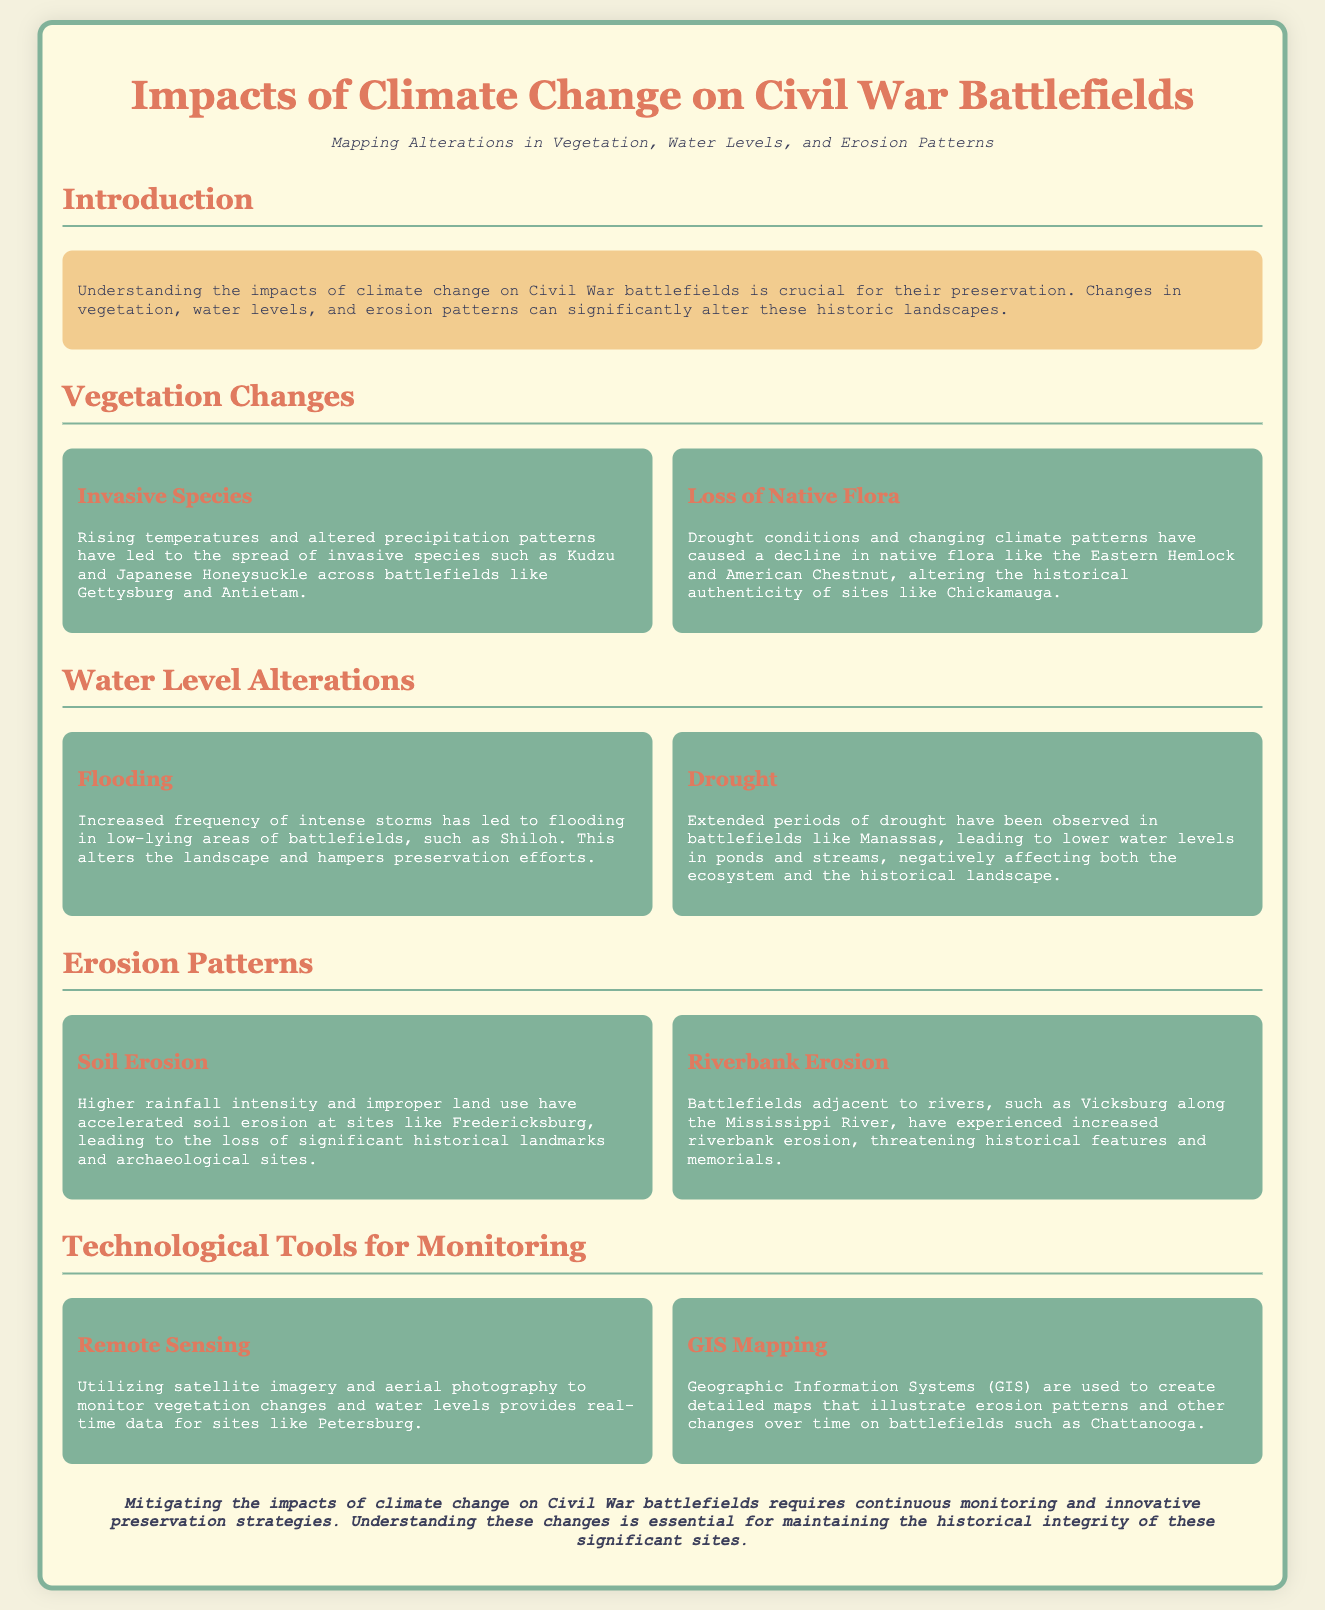What are two invasive species mentioned? The document states that rising temperatures and altered precipitation patterns have led to the spread of invasive species such as Kudzu and Japanese Honeysuckle.
Answer: Kudzu and Japanese Honeysuckle What is one native flora mentioned that is declining? Drought conditions and changing climate patterns have caused a decline in native flora like the Eastern Hemlock and American Chestnut.
Answer: Eastern Hemlock Which battlefield experienced flooding? The document indicates that increased frequency of intense storms has led to flooding in low-lying areas of battlefields, such as Shiloh.
Answer: Shiloh What technological tool is used to monitor vegetation changes? The document mentions using satellite imagery and aerial photography to monitor vegetation changes as part of Remote Sensing.
Answer: Remote Sensing What is a consequence of extended periods of drought on battlefields? The document states that extended periods of drought have been observed in battlefields like Manassas, leading to lower water levels in ponds and streams.
Answer: Lower water levels What type of erosion is exacerbated by higher rainfall intensity? The document notes that higher rainfall intensity has accelerated soil erosion at sites like Fredericksburg.
Answer: Soil erosion Which river is associated with increased riverbank erosion? The document states that battlefields adjacent to rivers, such as Vicksburg along the Mississippi River, have experienced increased riverbank erosion.
Answer: Mississippi River What is the main focus of the geographic infographic? The infographic focuses on mapping alterations in vegetation, water levels, and erosion patterns on Civil War battlefields due to climate change.
Answer: Climate change impacts 